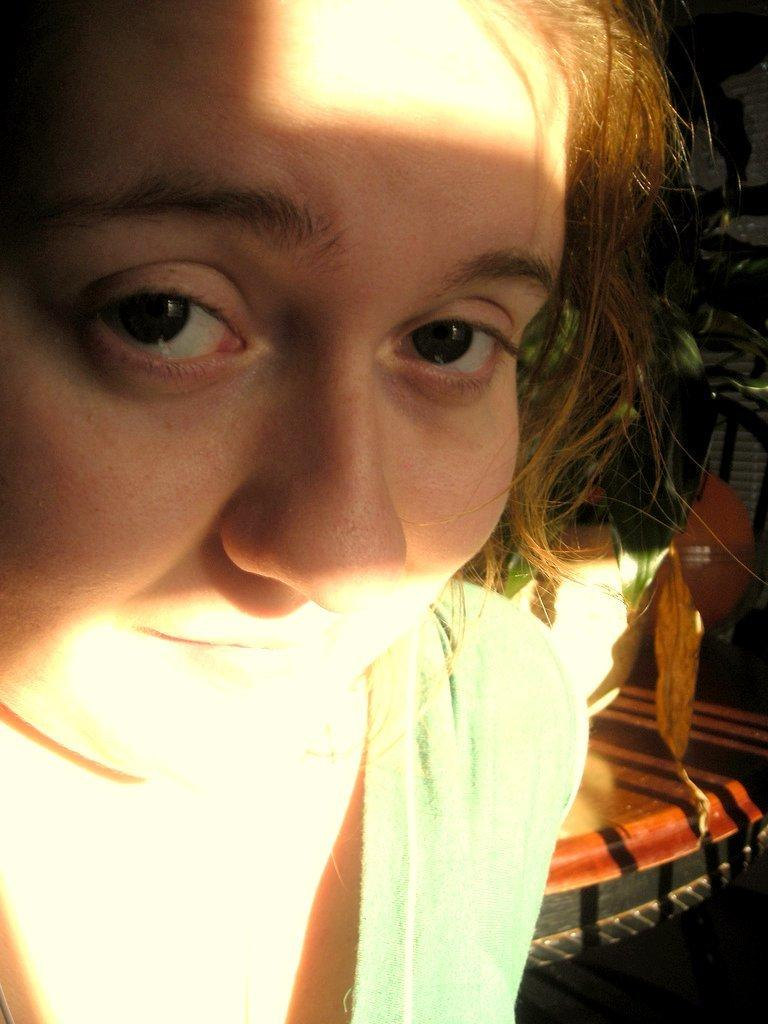Who is present in the image? There is a woman in the image. What is the woman wearing? The woman is wearing a green dress. What can be seen on the right side of the image? There are objects on the right side of the image. What type of sound can be heard coming from the sea in the image? There is no sea present in the image, so it's not possible to determine what, if any, sounds might be heard. 